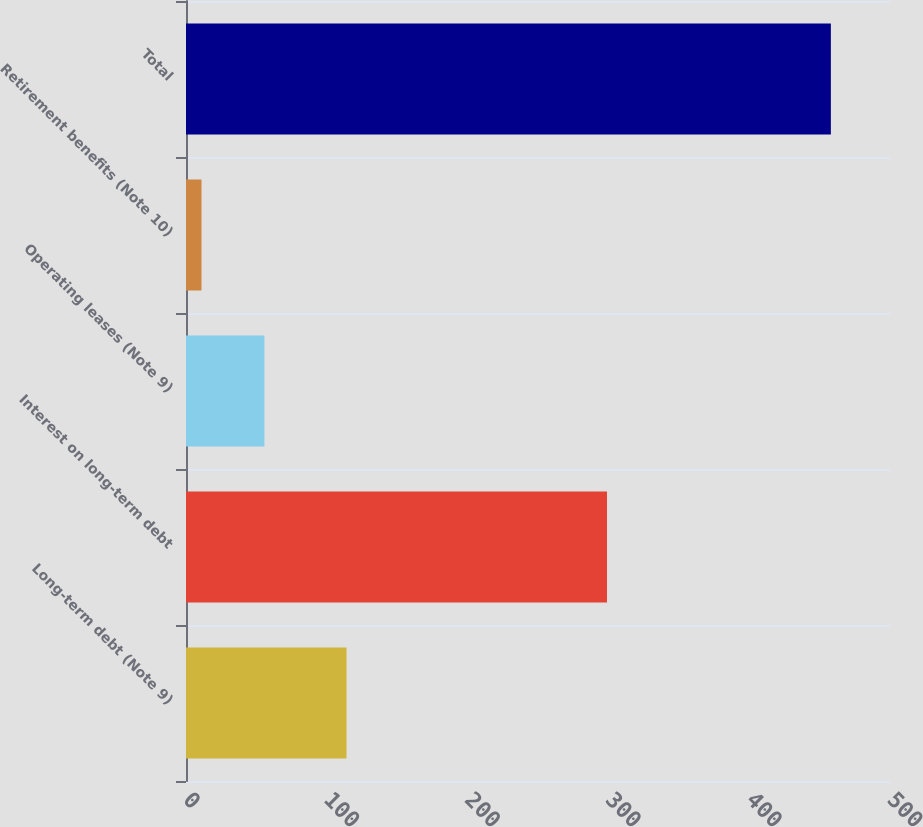<chart> <loc_0><loc_0><loc_500><loc_500><bar_chart><fcel>Long-term debt (Note 9)<fcel>Interest on long-term debt<fcel>Operating leases (Note 9)<fcel>Retirement benefits (Note 10)<fcel>Total<nl><fcel>114<fcel>299<fcel>55.7<fcel>11<fcel>458<nl></chart> 